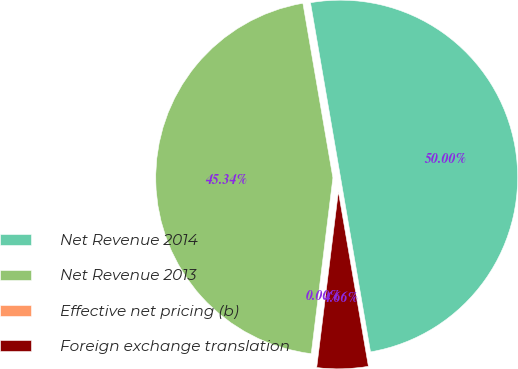Convert chart to OTSL. <chart><loc_0><loc_0><loc_500><loc_500><pie_chart><fcel>Net Revenue 2014<fcel>Net Revenue 2013<fcel>Effective net pricing (b)<fcel>Foreign exchange translation<nl><fcel>50.0%<fcel>45.34%<fcel>0.0%<fcel>4.66%<nl></chart> 